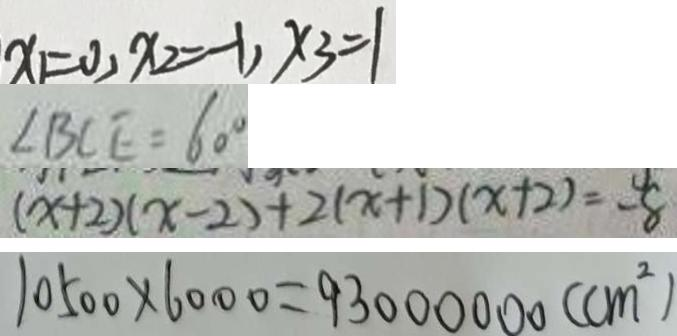<formula> <loc_0><loc_0><loc_500><loc_500>x _ { 1 } = 0 , x _ { 2 } = - 1 , x _ { 3 } = 1 
 \angle B C E = 6 0 ^ { \circ } 
 ( x + 2 ) ( x - 2 ) + 2 ( x + 1 ) ( x + 2 ) = - 8 
 1 0 5 0 0 \times 6 0 0 0 = 9 3 0 0 0 0 0 0 ( c m ^ { 2 } )</formula> 